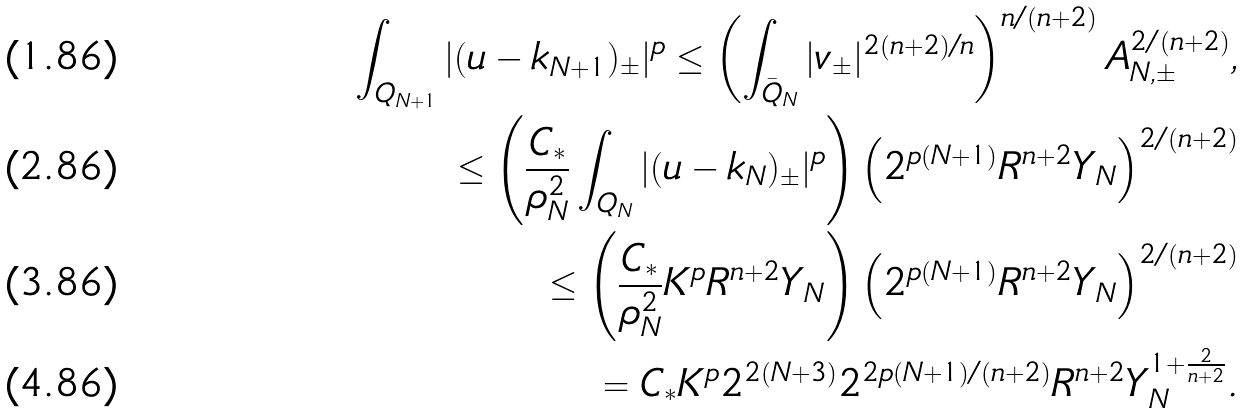<formula> <loc_0><loc_0><loc_500><loc_500>\int _ { Q _ { N + 1 } } | ( u - k _ { N + 1 } ) _ { \pm } | ^ { p } \leq \left ( \int _ { \bar { Q } _ { N } } | v _ { \pm } | ^ { 2 ( n + 2 ) / n } \right ) ^ { n / ( n + 2 ) } A _ { N , \pm } ^ { 2 / ( n + 2 ) } , \\ \leq \left ( \frac { C _ { * } } { \rho _ { N } ^ { 2 } } \int _ { Q _ { N } } | ( u - k _ { N } ) _ { \pm } | ^ { p } \right ) \left ( 2 ^ { p ( N + 1 ) } R ^ { n + 2 } Y _ { N } \right ) ^ { 2 / ( n + 2 ) } \\ \leq \left ( \frac { C _ { * } } { \rho _ { N } ^ { 2 } } K ^ { p } R ^ { n + 2 } Y _ { N } \right ) \left ( 2 ^ { p ( N + 1 ) } R ^ { n + 2 } Y _ { N } \right ) ^ { 2 / ( n + 2 ) } \\ = C _ { * } K ^ { p } 2 ^ { 2 ( N + 3 ) } 2 ^ { 2 p ( N + 1 ) / ( n + 2 ) } R ^ { n + 2 } Y _ { N } ^ { 1 + \frac { 2 } { n + 2 } } .</formula> 